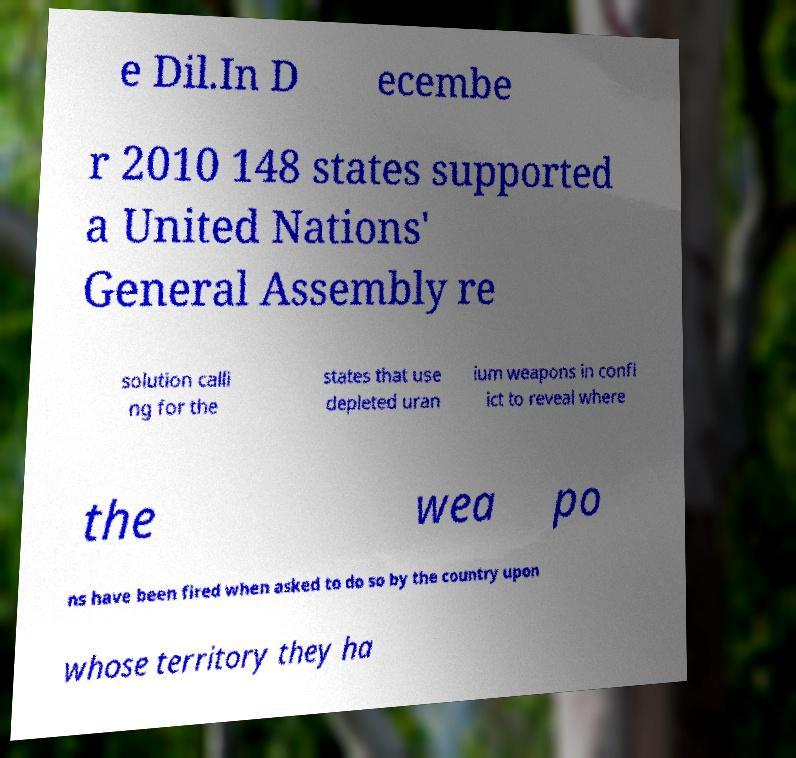I need the written content from this picture converted into text. Can you do that? e Dil.In D ecembe r 2010 148 states supported a United Nations' General Assembly re solution calli ng for the states that use depleted uran ium weapons in confl ict to reveal where the wea po ns have been fired when asked to do so by the country upon whose territory they ha 